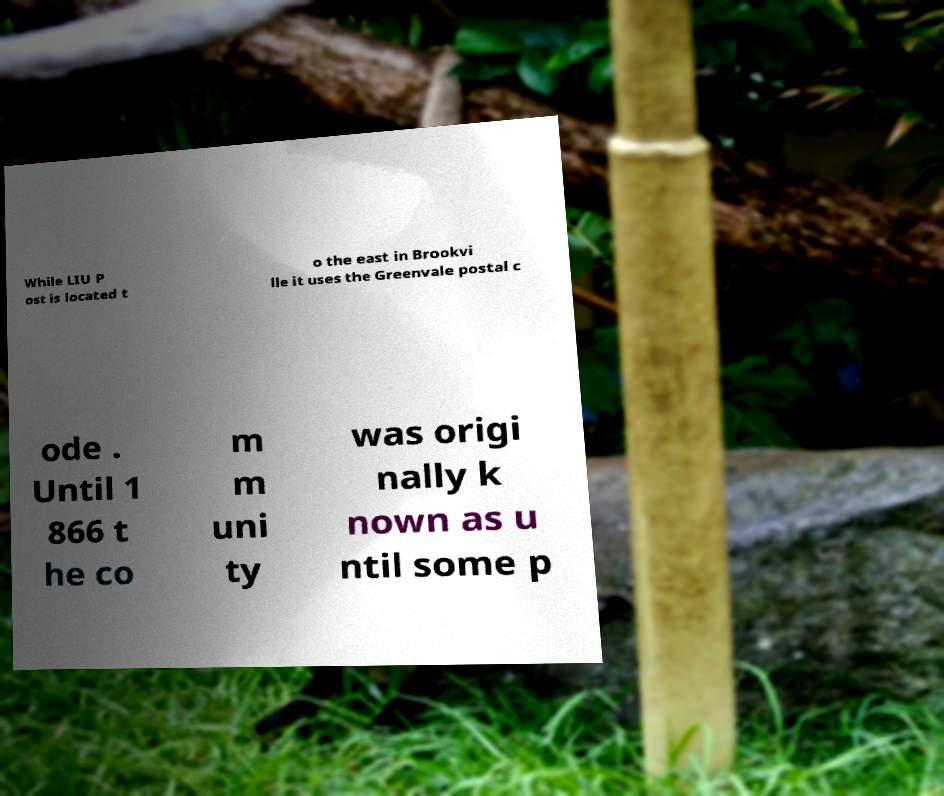Could you assist in decoding the text presented in this image and type it out clearly? While LIU P ost is located t o the east in Brookvi lle it uses the Greenvale postal c ode . Until 1 866 t he co m m uni ty was origi nally k nown as u ntil some p 